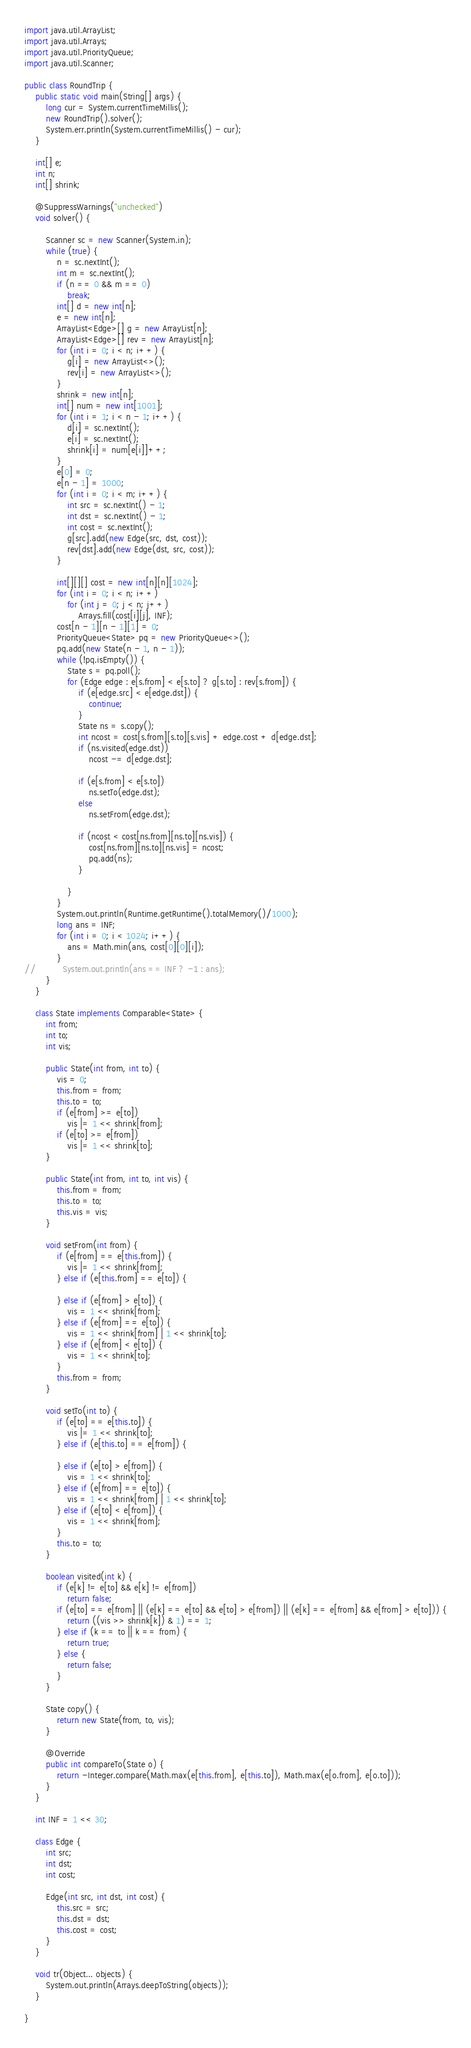Convert code to text. <code><loc_0><loc_0><loc_500><loc_500><_Java_>import java.util.ArrayList;
import java.util.Arrays;
import java.util.PriorityQueue;
import java.util.Scanner;

public class RoundTrip {
	public static void main(String[] args) {
		long cur = System.currentTimeMillis();
		new RoundTrip().solver();
		System.err.println(System.currentTimeMillis() - cur);
	}

	int[] e;
	int n;
	int[] shrink;

	@SuppressWarnings("unchecked")
	void solver() {

		Scanner sc = new Scanner(System.in);
		while (true) {
			n = sc.nextInt();
			int m = sc.nextInt();
			if (n == 0 && m == 0)
				break;
			int[] d = new int[n];
			e = new int[n];
			ArrayList<Edge>[] g = new ArrayList[n];
			ArrayList<Edge>[] rev = new ArrayList[n];
			for (int i = 0; i < n; i++) {
				g[i] = new ArrayList<>();
				rev[i] = new ArrayList<>();
			}
			shrink = new int[n];
			int[] num = new int[1001];
			for (int i = 1; i < n - 1; i++) {
				d[i] = sc.nextInt();
				e[i] = sc.nextInt();
				shrink[i] = num[e[i]]++;
			}
			e[0] = 0;
			e[n - 1] = 1000;
			for (int i = 0; i < m; i++) {
				int src = sc.nextInt() - 1;
				int dst = sc.nextInt() - 1;
				int cost = sc.nextInt();
				g[src].add(new Edge(src, dst, cost));
				rev[dst].add(new Edge(dst, src, cost));
			}

			int[][][] cost = new int[n][n][1024];
			for (int i = 0; i < n; i++)
				for (int j = 0; j < n; j++)
					Arrays.fill(cost[i][j], INF);
			cost[n - 1][n - 1][1] = 0;
			PriorityQueue<State> pq = new PriorityQueue<>();
			pq.add(new State(n - 1, n - 1));
			while (!pq.isEmpty()) {
				State s = pq.poll();
				for (Edge edge : e[s.from] < e[s.to] ? g[s.to] : rev[s.from]) {
					if (e[edge.src] < e[edge.dst]) {
						continue;
					}
					State ns = s.copy();
					int ncost = cost[s.from][s.to][s.vis] + edge.cost + d[edge.dst];
					if (ns.visited(edge.dst))
						ncost -= d[edge.dst];

					if (e[s.from] < e[s.to])
						ns.setTo(edge.dst);
					else
						ns.setFrom(edge.dst);

					if (ncost < cost[ns.from][ns.to][ns.vis]) {
						cost[ns.from][ns.to][ns.vis] = ncost;
						pq.add(ns);
					}

				}
			}
			System.out.println(Runtime.getRuntime().totalMemory()/1000);
			long ans = INF;
			for (int i = 0; i < 1024; i++) {
				ans = Math.min(ans, cost[0][0][i]);
			}
//			System.out.println(ans == INF ? -1 : ans);
		}
	}

	class State implements Comparable<State> {
		int from;
		int to;
		int vis;

		public State(int from, int to) {
			vis = 0;
			this.from = from;
			this.to = to;
			if (e[from] >= e[to])
				vis |= 1 << shrink[from];
			if (e[to] >= e[from])
				vis |= 1 << shrink[to];
		}

		public State(int from, int to, int vis) {
			this.from = from;
			this.to = to;
			this.vis = vis;
		}

		void setFrom(int from) {
			if (e[from] == e[this.from]) {
				vis |= 1 << shrink[from];
			} else if (e[this.from] == e[to]) {

			} else if (e[from] > e[to]) {
				vis = 1 << shrink[from];
			} else if (e[from] == e[to]) {
				vis = 1 << shrink[from] | 1 << shrink[to];
			} else if (e[from] < e[to]) {
				vis = 1 << shrink[to];
			}
			this.from = from;
		}

		void setTo(int to) {
			if (e[to] == e[this.to]) {
				vis |= 1 << shrink[to];
			} else if (e[this.to] == e[from]) {

			} else if (e[to] > e[from]) {
				vis = 1 << shrink[to];
			} else if (e[from] == e[to]) {
				vis = 1 << shrink[from] | 1 << shrink[to];
			} else if (e[to] < e[from]) {
				vis = 1 << shrink[from];
			}
			this.to = to;
		}

		boolean visited(int k) {
			if (e[k] != e[to] && e[k] != e[from])
				return false;
			if (e[to] == e[from] || (e[k] == e[to] && e[to] > e[from]) || (e[k] == e[from] && e[from] > e[to])) {
				return ((vis >> shrink[k]) & 1) == 1;
			} else if (k == to || k == from) {
				return true;
			} else {
				return false;
			}
		}

		State copy() {
			return new State(from, to, vis);
		}

		@Override
		public int compareTo(State o) {
			return -Integer.compare(Math.max(e[this.from], e[this.to]), Math.max(e[o.from], e[o.to]));
		}
	}

	int INF = 1 << 30;

	class Edge {
		int src;
		int dst;
		int cost;

		Edge(int src, int dst, int cost) {
			this.src = src;
			this.dst = dst;
			this.cost = cost;
		}
	}

	void tr(Object... objects) {
		System.out.println(Arrays.deepToString(objects));
	}

}</code> 